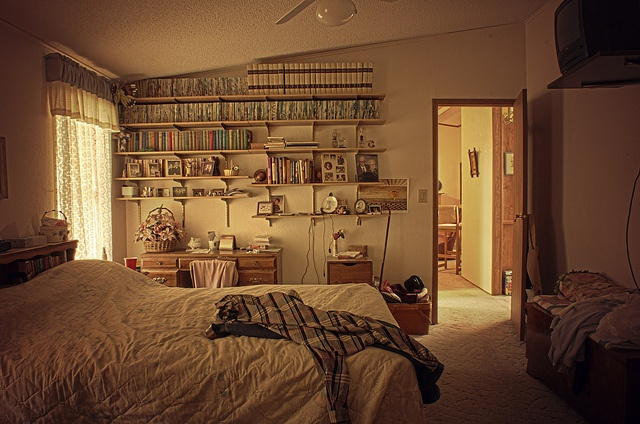Describe the objects in this image and their specific colors. I can see bed in black, maroon, and brown tones, book in black, maroon, brown, and olive tones, tv in black and maroon tones, book in black, maroon, brown, and gray tones, and chair in black, gray, tan, and brown tones in this image. 